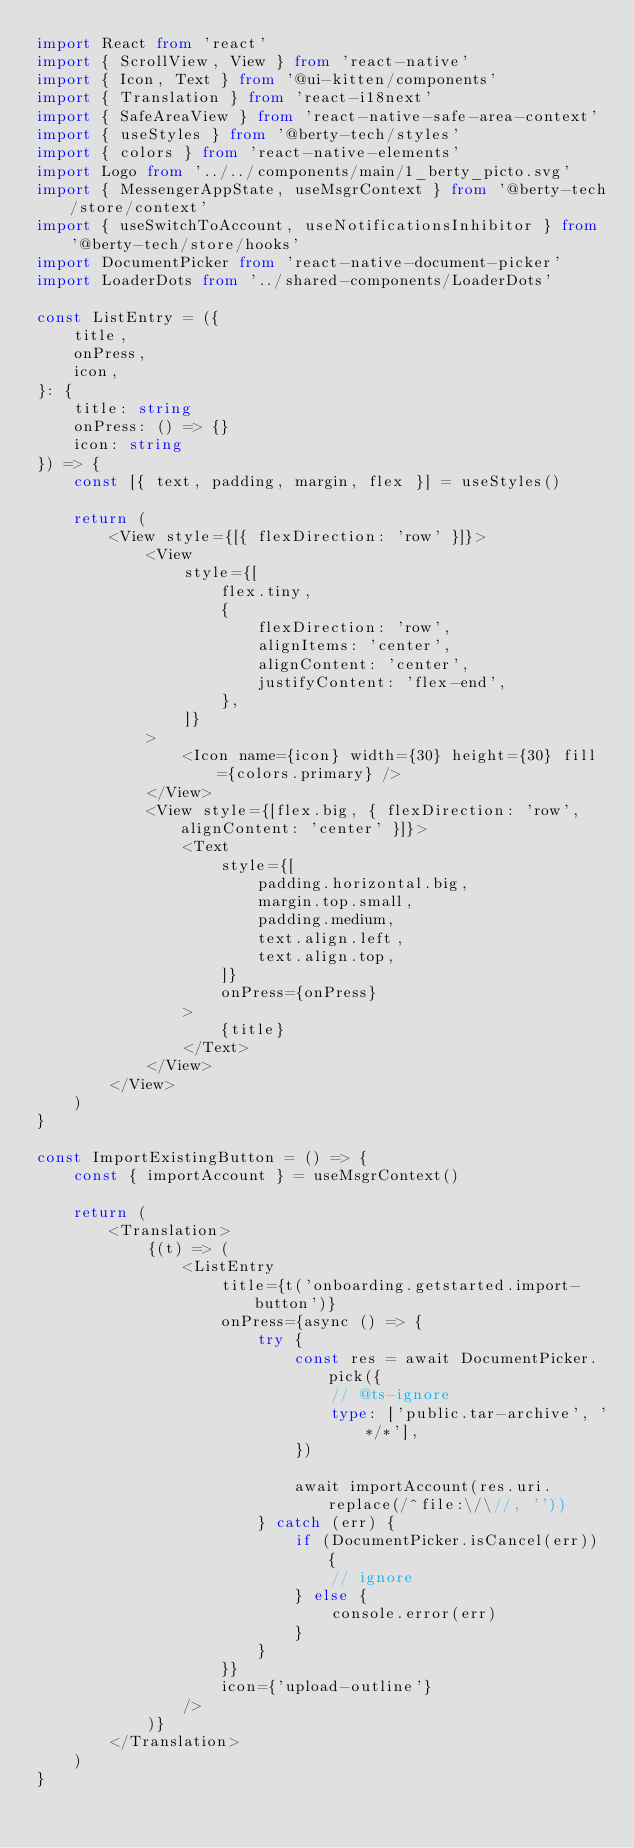Convert code to text. <code><loc_0><loc_0><loc_500><loc_500><_TypeScript_>import React from 'react'
import { ScrollView, View } from 'react-native'
import { Icon, Text } from '@ui-kitten/components'
import { Translation } from 'react-i18next'
import { SafeAreaView } from 'react-native-safe-area-context'
import { useStyles } from '@berty-tech/styles'
import { colors } from 'react-native-elements'
import Logo from '../../components/main/1_berty_picto.svg'
import { MessengerAppState, useMsgrContext } from '@berty-tech/store/context'
import { useSwitchToAccount, useNotificationsInhibitor } from '@berty-tech/store/hooks'
import DocumentPicker from 'react-native-document-picker'
import LoaderDots from '../shared-components/LoaderDots'

const ListEntry = ({
	title,
	onPress,
	icon,
}: {
	title: string
	onPress: () => {}
	icon: string
}) => {
	const [{ text, padding, margin, flex }] = useStyles()

	return (
		<View style={[{ flexDirection: 'row' }]}>
			<View
				style={[
					flex.tiny,
					{
						flexDirection: 'row',
						alignItems: 'center',
						alignContent: 'center',
						justifyContent: 'flex-end',
					},
				]}
			>
				<Icon name={icon} width={30} height={30} fill={colors.primary} />
			</View>
			<View style={[flex.big, { flexDirection: 'row', alignContent: 'center' }]}>
				<Text
					style={[
						padding.horizontal.big,
						margin.top.small,
						padding.medium,
						text.align.left,
						text.align.top,
					]}
					onPress={onPress}
				>
					{title}
				</Text>
			</View>
		</View>
	)
}

const ImportExistingButton = () => {
	const { importAccount } = useMsgrContext()

	return (
		<Translation>
			{(t) => (
				<ListEntry
					title={t('onboarding.getstarted.import-button')}
					onPress={async () => {
						try {
							const res = await DocumentPicker.pick({
								// @ts-ignore
								type: ['public.tar-archive', '*/*'],
							})

							await importAccount(res.uri.replace(/^file:\/\//, ''))
						} catch (err) {
							if (DocumentPicker.isCancel(err)) {
								// ignore
							} else {
								console.error(err)
							}
						}
					}}
					icon={'upload-outline'}
				/>
			)}
		</Translation>
	)
}
</code> 